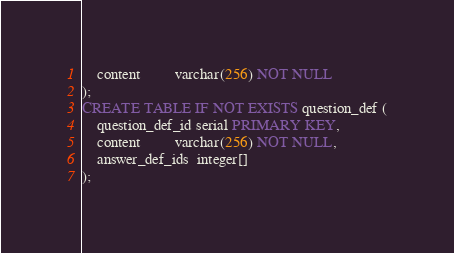<code> <loc_0><loc_0><loc_500><loc_500><_SQL_>    content         varchar(256) NOT NULL
);
CREATE TABLE IF NOT EXISTS question_def (
    question_def_id serial PRIMARY KEY,
    content         varchar(256) NOT NULL,
    answer_def_ids  integer[]
);
</code> 